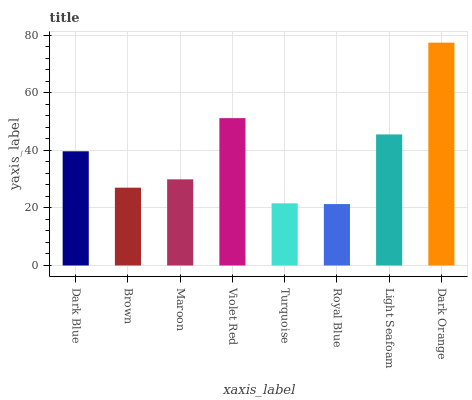Is Brown the minimum?
Answer yes or no. No. Is Brown the maximum?
Answer yes or no. No. Is Dark Blue greater than Brown?
Answer yes or no. Yes. Is Brown less than Dark Blue?
Answer yes or no. Yes. Is Brown greater than Dark Blue?
Answer yes or no. No. Is Dark Blue less than Brown?
Answer yes or no. No. Is Dark Blue the high median?
Answer yes or no. Yes. Is Maroon the low median?
Answer yes or no. Yes. Is Light Seafoam the high median?
Answer yes or no. No. Is Dark Blue the low median?
Answer yes or no. No. 